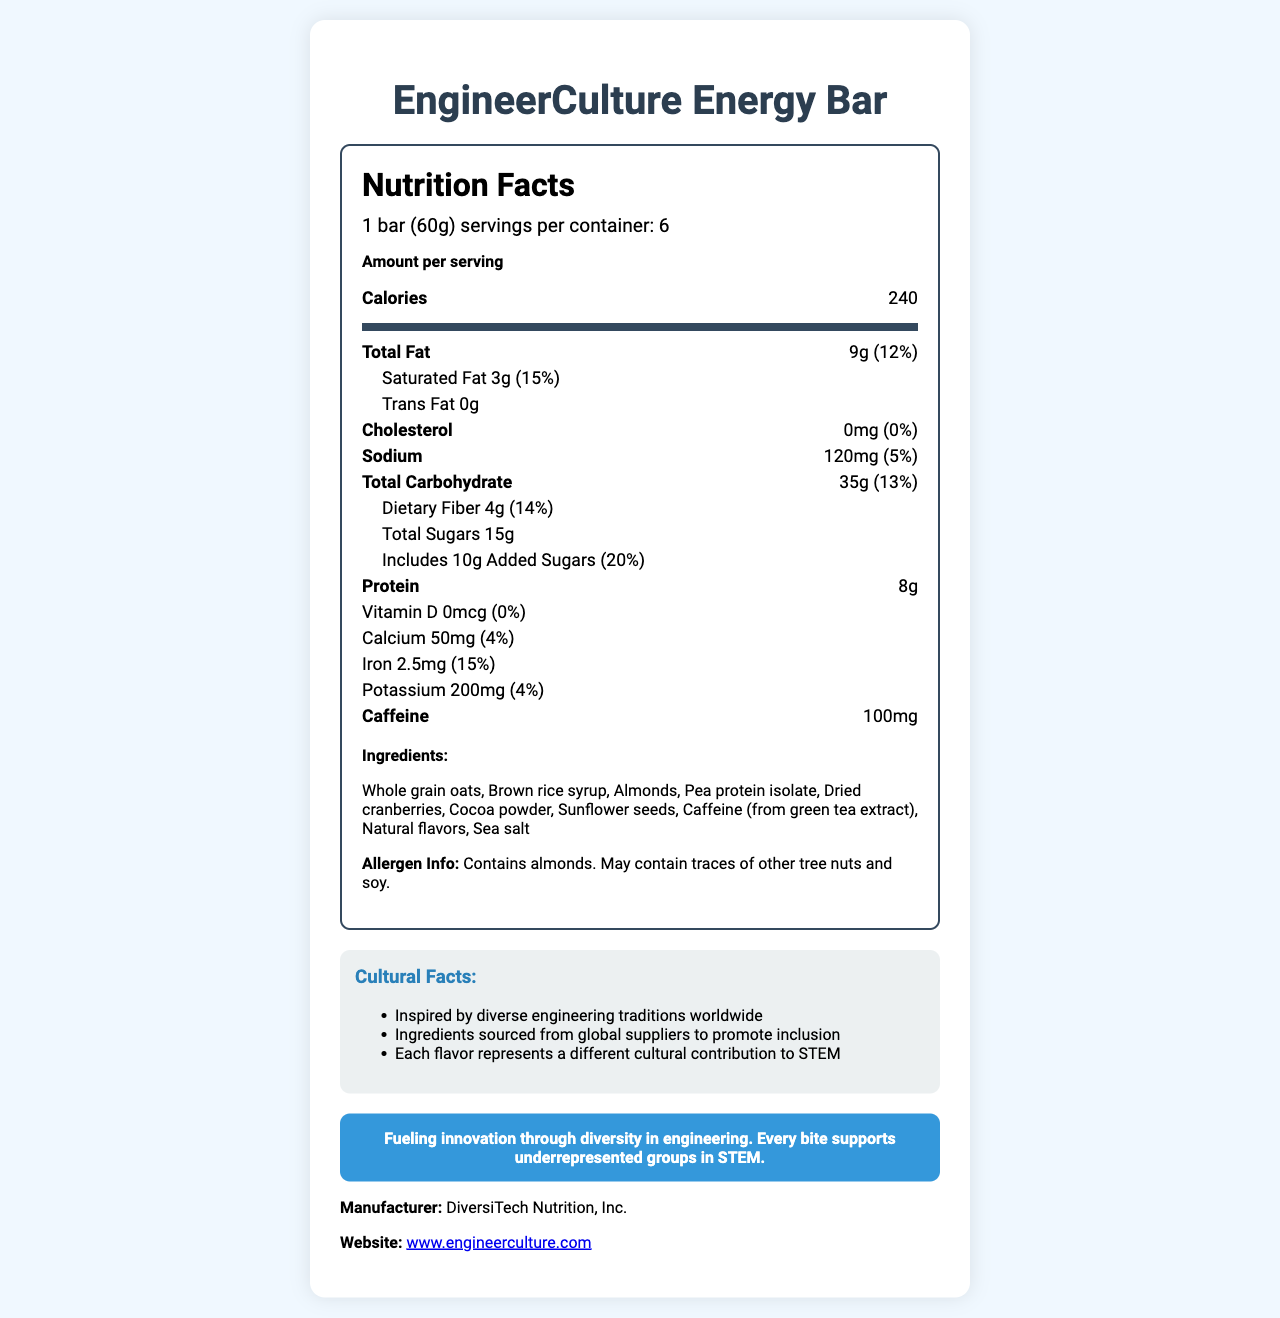what is the product name? The product name is clearly listed at the beginning of the document.
Answer: EngineerCulture Energy Bar how many calories are in one serving? The calories per serving are listed in the "amount per serving" section.
Answer: 240 what is the serving size? The serving size is listed in the document under the product name and in the serving info section.
Answer: 1 bar (60g) what are the total carbohydrates in one bar? The total carbohydrates are listed under the nutrition facts as 35g with a daily value of 13%.
Answer: 35g (13%) how much caffeine does one bar contain? The amount of caffeine is listed at the bottom of the nutrition facts label under "Caffeine".
Answer: 100mg what ingredients are used in this bar? The ingredients are listed in a section labeled "Ingredients".
Answer: Whole grain oats, Brown rice syrup, Almonds, Pea protein isolate, Dried cranberries, Cocoa powder, Sunflower seeds, Caffeine (from green tea extract), Natural flavors, Sea salt how much protein is in one serving? The protein content per serving is listed in the nutrition facts section.
Answer: 8g how much of the daily value is the iron content? A. 4% B. 10% C. 15% D. 20% The iron content is listed as 2.5mg, which represents 15% of the daily value.
Answer: C. 15% which of these flavors might you find in EngineerCulture Energy Bar(s)? A. Vanilla B. Cocoa C. Citrus Cocoa powder is mentioned in the ingredients, while vanilla and citrus are not mentioned.
Answer: B. Cocoa is the product suitable for people with tree nut allergies? The allergen info states that the product contains almonds and may contain traces of other tree nuts.
Answer: No is this product supporting any social causes? The product's message indicates it supports underrepresented groups in STEM with each bite.
Answer: Yes can you determine the exact nutritional impact of the 'Natural flavors' ingredient? The document lists "Natural flavors" as an ingredient, but does not provide specific nutritional details about it.
Answer: Not enough information summarize the main idea of this document. The label includes nutrition facts, ingredients, allergen info, and a message about supporting diversity in STEM, along with some cultural facts and manufacturer information.
Answer: The document is a nutrition facts label for the EngineerCulture Energy Bar that provides detailed information on its nutritional content, ingredients, and cultural significance, highlighting its support for diversity in STEM fields. how much sodium is in one bar? The sodium content per serving is listed as 120mg, with a daily value of 5%.
Answer: 120mg (5%) what are the cultural facts associated with the product? The document lists these cultural facts in a separate section labeled "Cultural Facts".
Answer: Inspired by diverse engineering traditions worldwide; Ingredients sourced from global suppliers to promote inclusion; Each flavor represents a different cultural contribution to STEM how many servings are in one container? The number of servings per container is listed in the serving info section as 6 servings per container.
Answer: 6 which ingredients are directly related to providing dietary fiber? A. Whole grain oats B. Brown rice syrup C. Almonds D. Sunflower seeds Whole grain oats, almonds, and sunflower seeds are all ingredients known to contribute dietary fiber.
Answer: A, C, D 